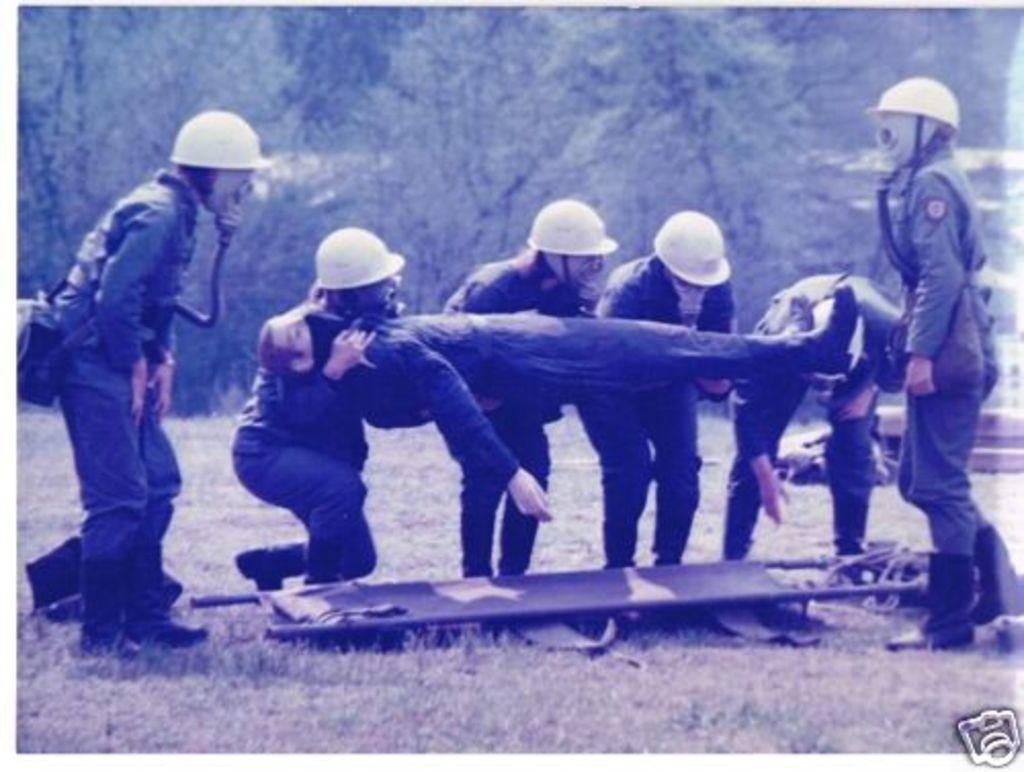How many people are in the image? There is a group of people in the image. What are the people in the image doing? The people are standing and holding another person. What can be seen in the background of the image? The background of the image includes trees. What is the color scheme of the image? The image is in black and white. What type of toy can be seen on the calculator in the image? There is no toy or calculator present in the image. How many tickets are visible in the image? There are no tickets visible in the image. 